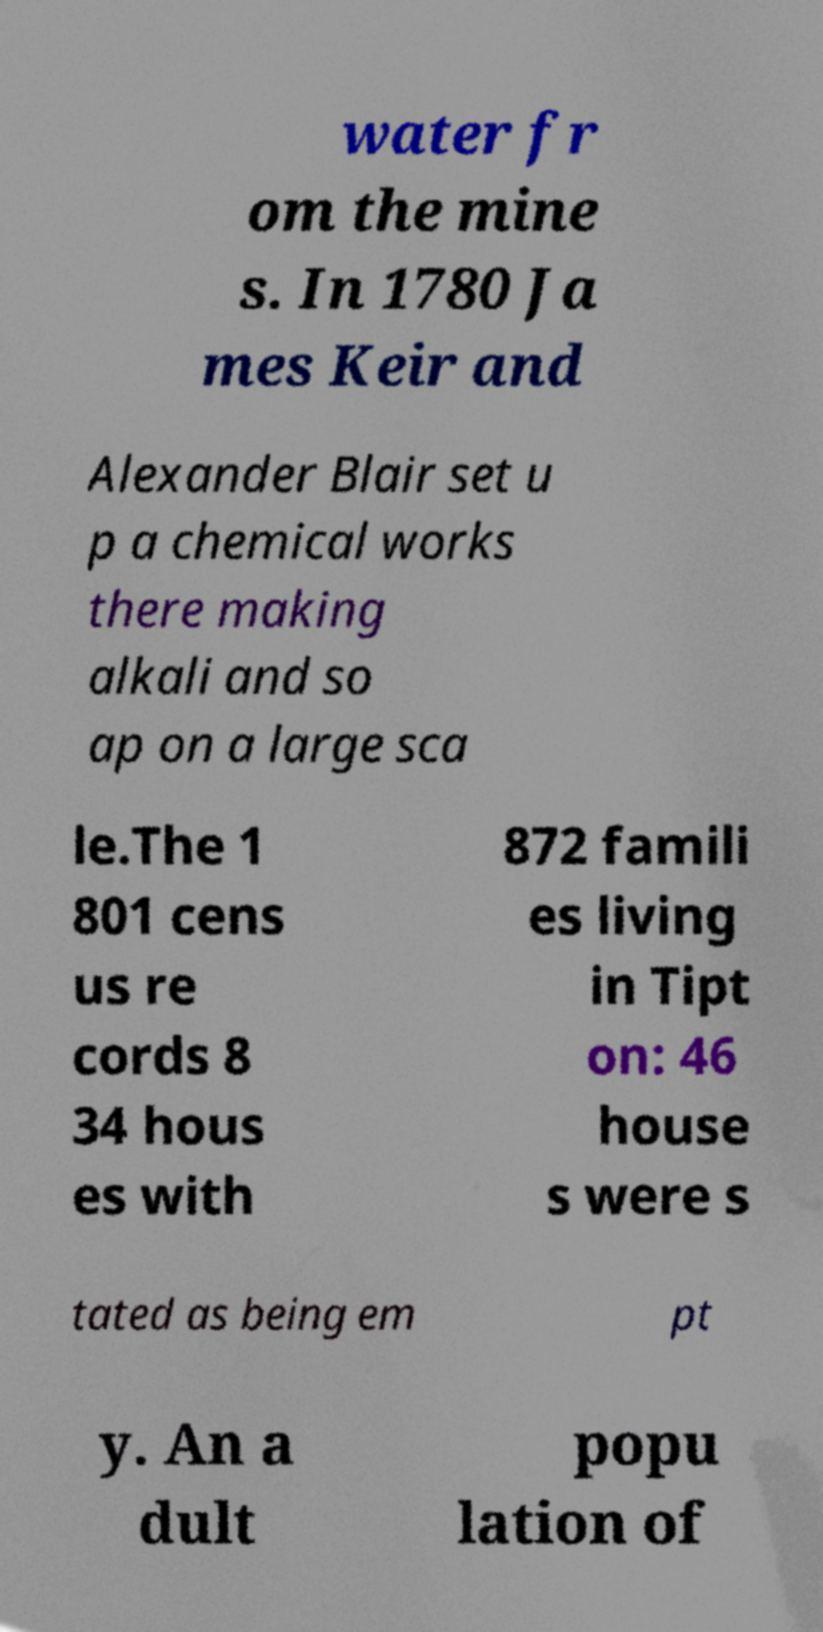Can you accurately transcribe the text from the provided image for me? water fr om the mine s. In 1780 Ja mes Keir and Alexander Blair set u p a chemical works there making alkali and so ap on a large sca le.The 1 801 cens us re cords 8 34 hous es with 872 famili es living in Tipt on: 46 house s were s tated as being em pt y. An a dult popu lation of 